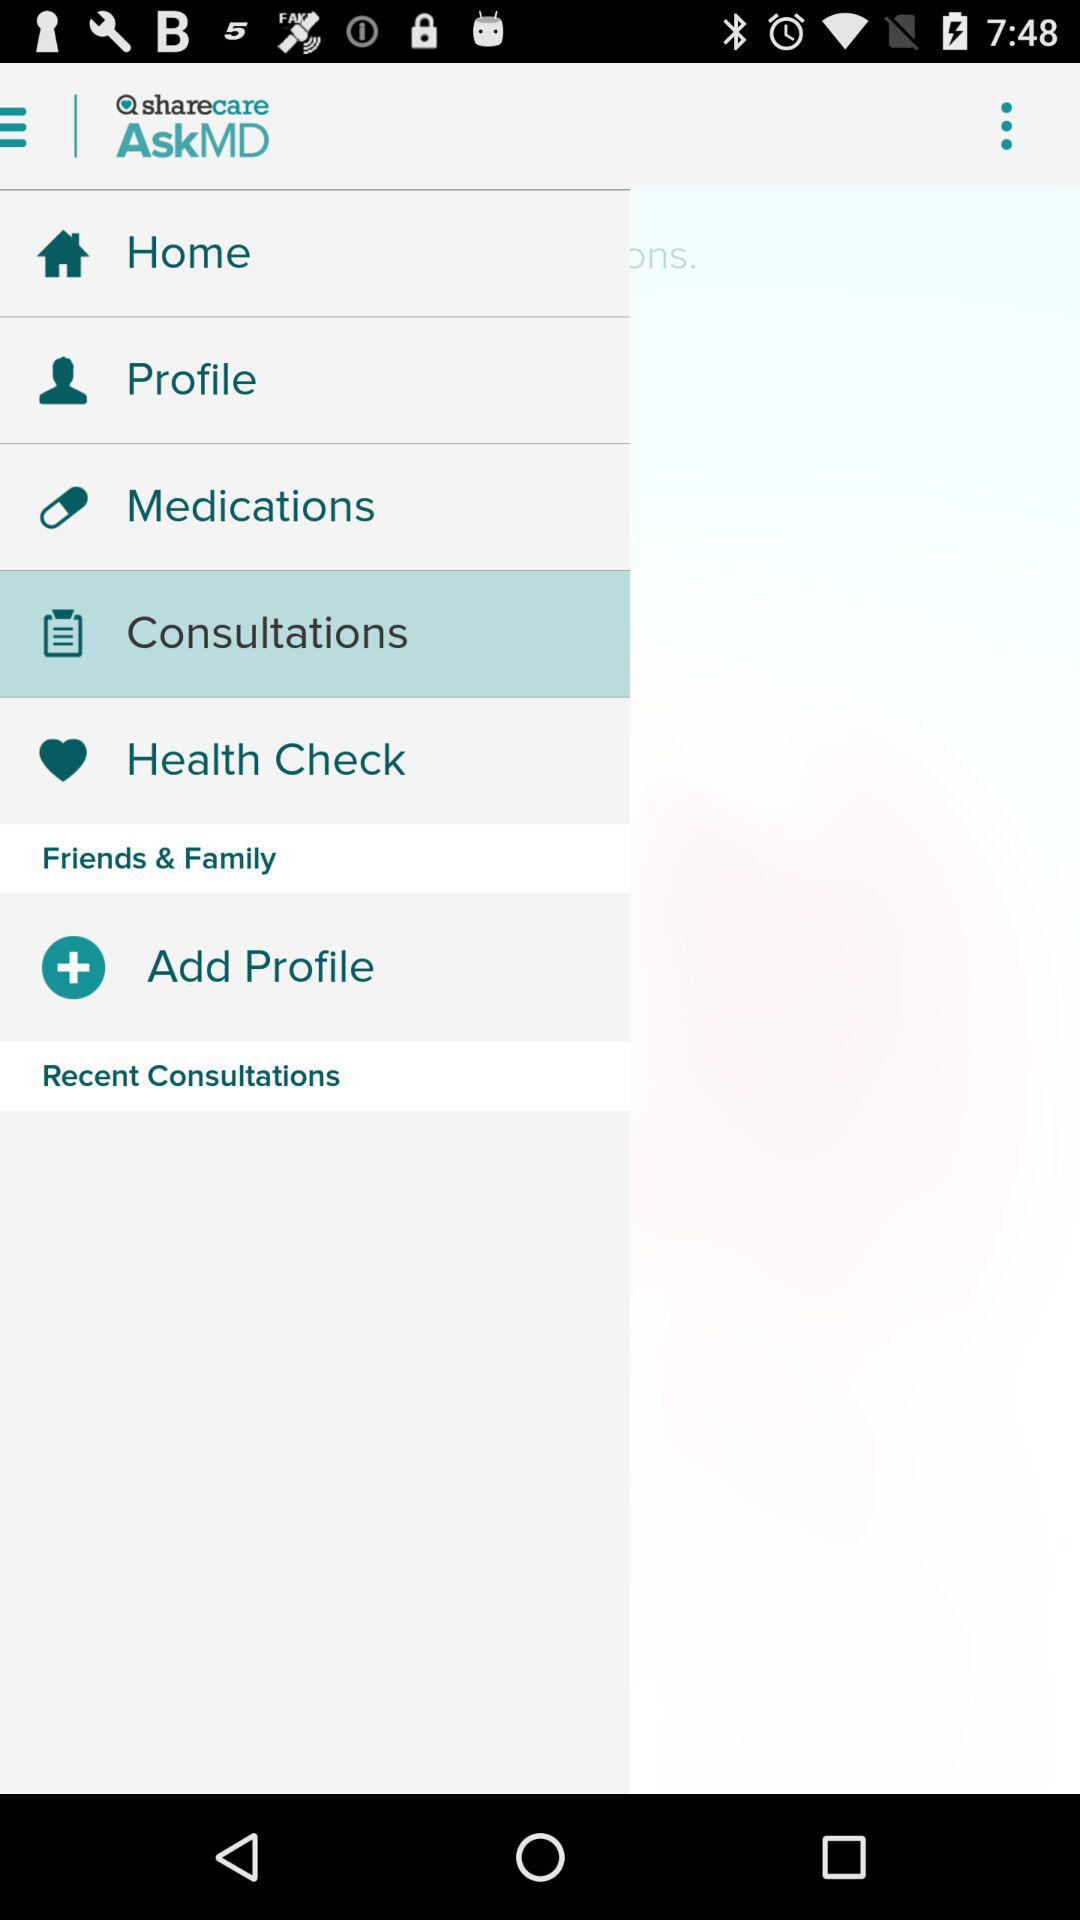Which option is selected? The selected option is consultations. 